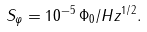Convert formula to latex. <formula><loc_0><loc_0><loc_500><loc_500>S _ { \varphi } = 1 0 ^ { - 5 } \, \Phi _ { 0 } / H z ^ { 1 / 2 } .</formula> 